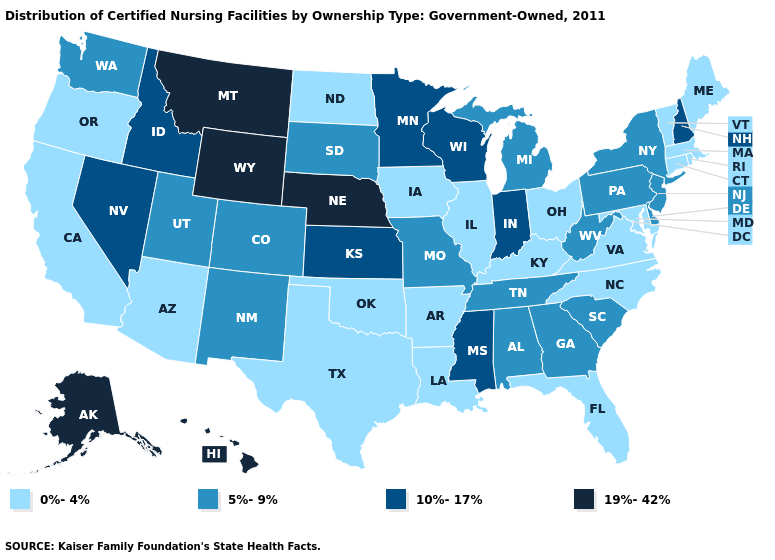What is the value of North Dakota?
Be succinct. 0%-4%. What is the lowest value in the South?
Concise answer only. 0%-4%. Does Hawaii have the highest value in the USA?
Keep it brief. Yes. Name the states that have a value in the range 5%-9%?
Concise answer only. Alabama, Colorado, Delaware, Georgia, Michigan, Missouri, New Jersey, New Mexico, New York, Pennsylvania, South Carolina, South Dakota, Tennessee, Utah, Washington, West Virginia. What is the lowest value in the USA?
Give a very brief answer. 0%-4%. What is the value of New Hampshire?
Quick response, please. 10%-17%. Does North Dakota have a higher value than Michigan?
Answer briefly. No. What is the lowest value in the USA?
Keep it brief. 0%-4%. Among the states that border Nebraska , does Colorado have the lowest value?
Concise answer only. No. What is the value of Virginia?
Concise answer only. 0%-4%. Name the states that have a value in the range 0%-4%?
Write a very short answer. Arizona, Arkansas, California, Connecticut, Florida, Illinois, Iowa, Kentucky, Louisiana, Maine, Maryland, Massachusetts, North Carolina, North Dakota, Ohio, Oklahoma, Oregon, Rhode Island, Texas, Vermont, Virginia. What is the value of New Jersey?
Give a very brief answer. 5%-9%. What is the value of South Carolina?
Keep it brief. 5%-9%. What is the value of Alaska?
Keep it brief. 19%-42%. 